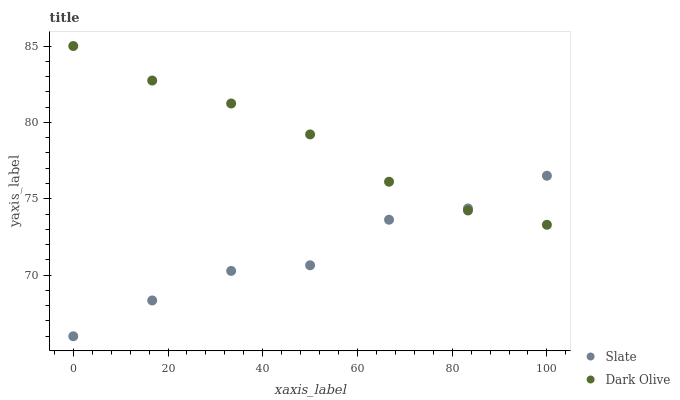Does Slate have the minimum area under the curve?
Answer yes or no. Yes. Does Dark Olive have the maximum area under the curve?
Answer yes or no. Yes. Does Dark Olive have the minimum area under the curve?
Answer yes or no. No. Is Dark Olive the smoothest?
Answer yes or no. Yes. Is Slate the roughest?
Answer yes or no. Yes. Is Dark Olive the roughest?
Answer yes or no. No. Does Slate have the lowest value?
Answer yes or no. Yes. Does Dark Olive have the lowest value?
Answer yes or no. No. Does Dark Olive have the highest value?
Answer yes or no. Yes. Does Slate intersect Dark Olive?
Answer yes or no. Yes. Is Slate less than Dark Olive?
Answer yes or no. No. Is Slate greater than Dark Olive?
Answer yes or no. No. 